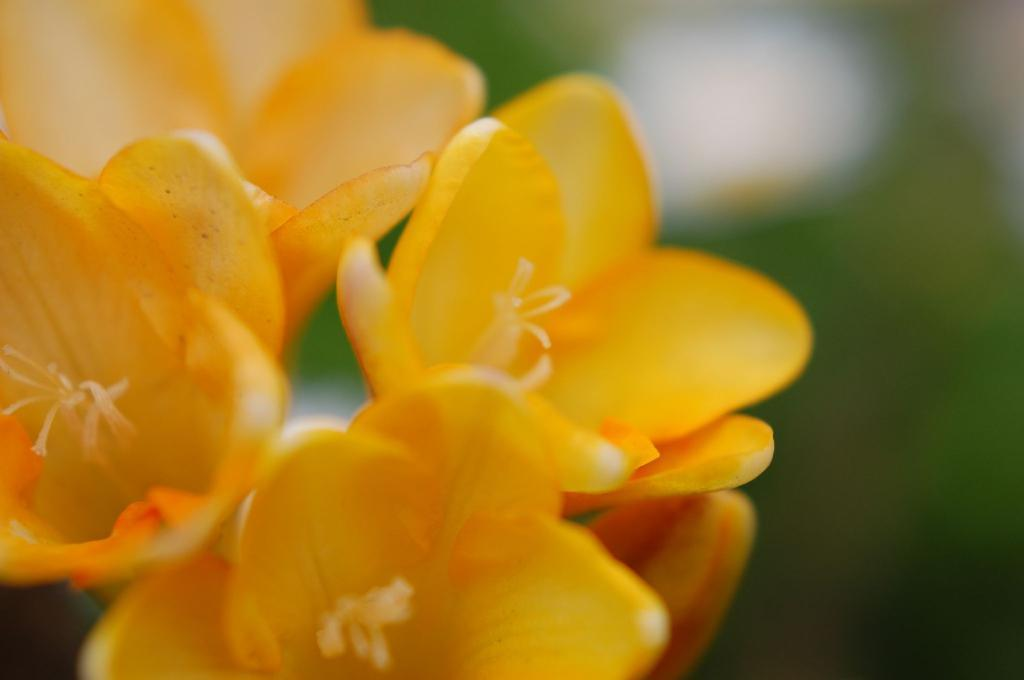What is the main subject of the image? The main subject of the image is a group of flowers. Can you describe the flowers in the image? Unfortunately, the facts provided do not give any details about the flowers, so we cannot describe them. Are there any other objects or elements in the image besides the flowers? The facts provided do not mention any other objects or elements in the image, so we cannot comment on their presence. What type of road can be seen in the background of the image? There is no road present in the image; it features a group of flowers. What company is responsible for the view in the image? There is no company mentioned in the image, and the facts provided do not suggest any involvement of a company. 